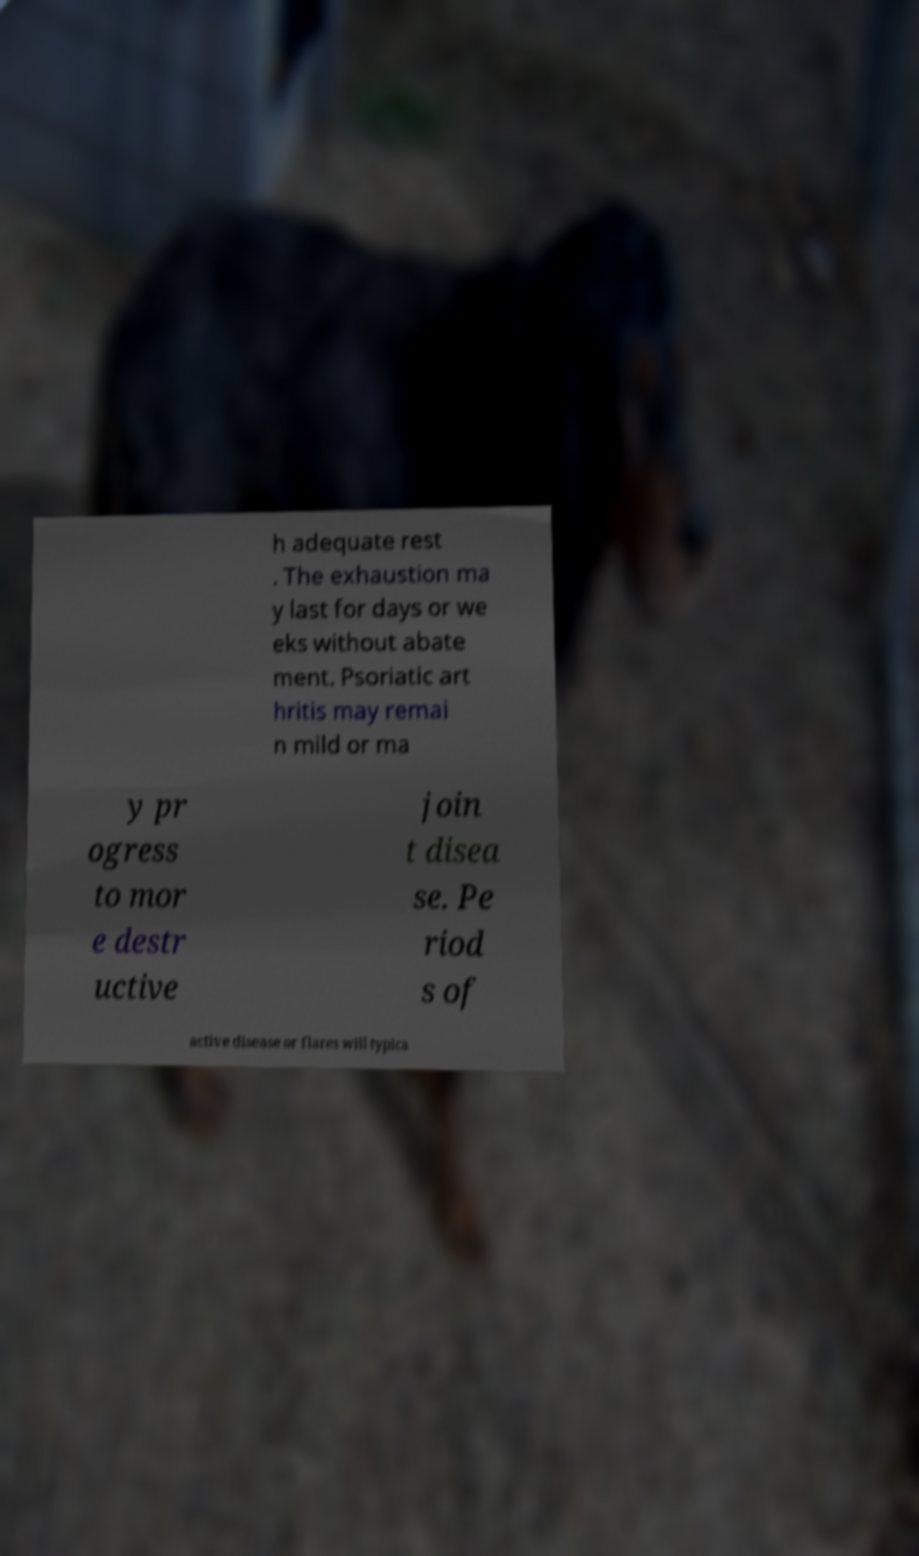What messages or text are displayed in this image? I need them in a readable, typed format. h adequate rest . The exhaustion ma y last for days or we eks without abate ment. Psoriatic art hritis may remai n mild or ma y pr ogress to mor e destr uctive join t disea se. Pe riod s of active disease or flares will typica 